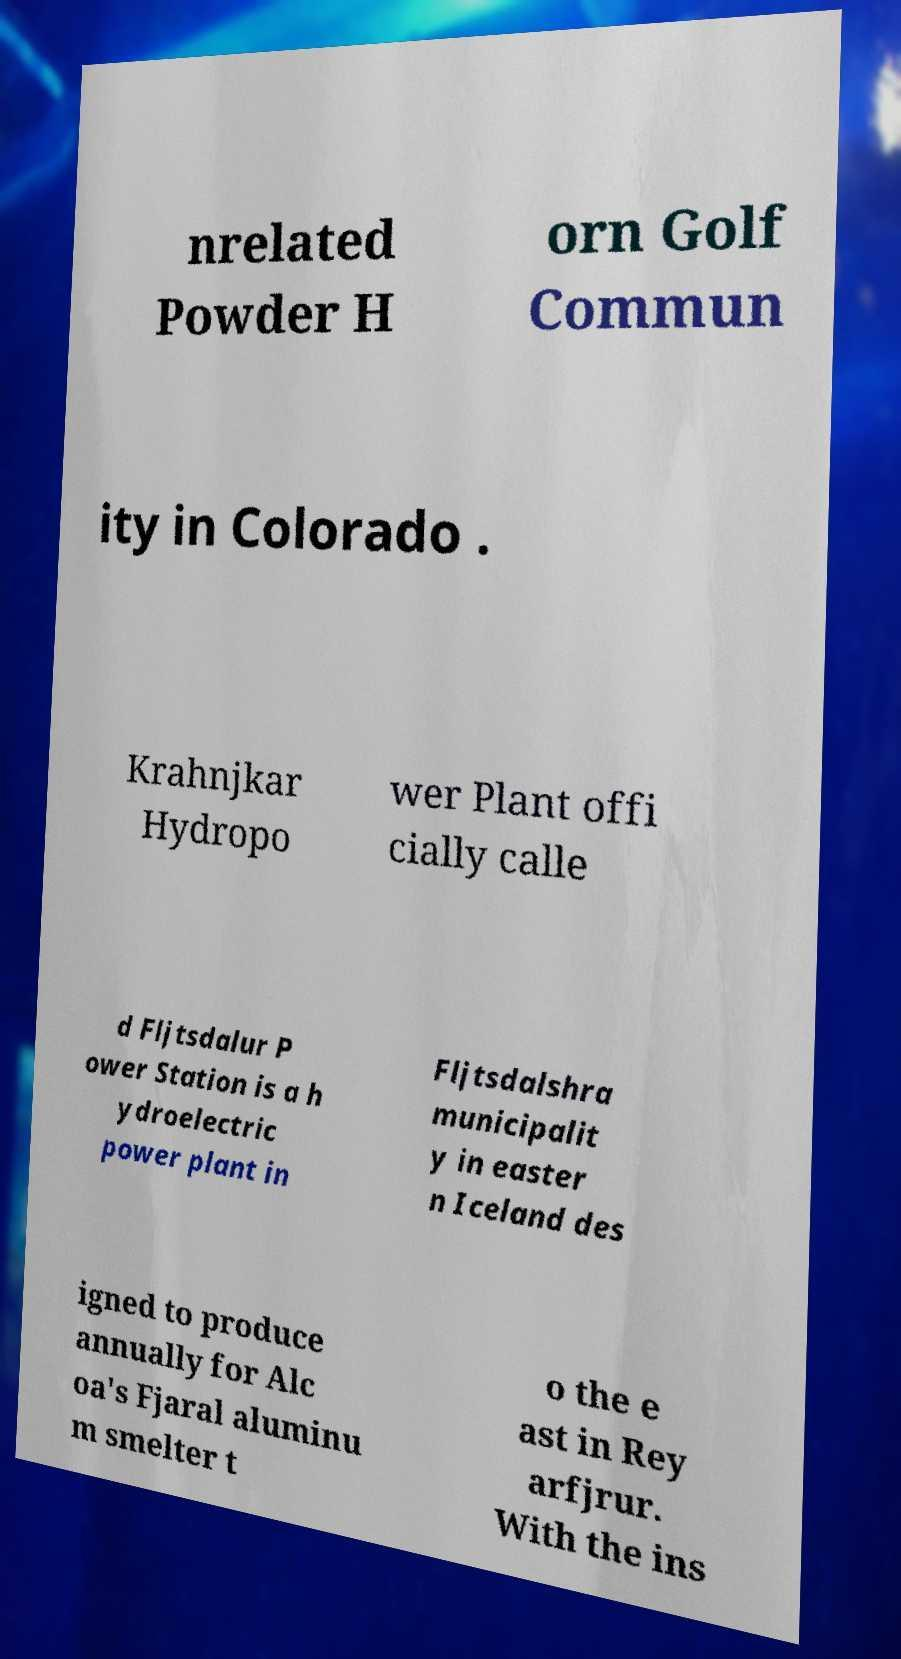Please identify and transcribe the text found in this image. nrelated Powder H orn Golf Commun ity in Colorado . Krahnjkar Hydropo wer Plant offi cially calle d Fljtsdalur P ower Station is a h ydroelectric power plant in Fljtsdalshra municipalit y in easter n Iceland des igned to produce annually for Alc oa's Fjaral aluminu m smelter t o the e ast in Rey arfjrur. With the ins 